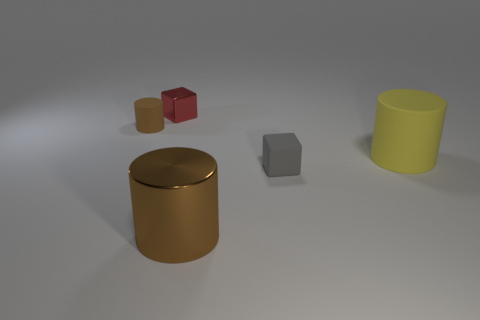Add 1 tiny green matte cylinders. How many objects exist? 6 Subtract all blocks. How many objects are left? 3 Add 4 yellow rubber objects. How many yellow rubber objects are left? 5 Add 5 large green blocks. How many large green blocks exist? 5 Subtract 0 purple spheres. How many objects are left? 5 Subtract all matte cylinders. Subtract all small matte blocks. How many objects are left? 2 